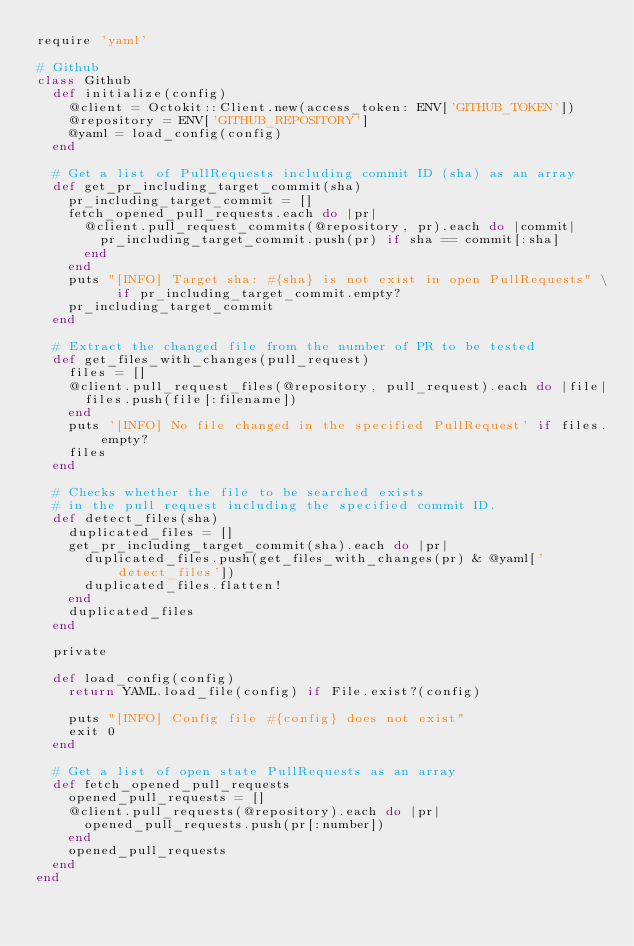<code> <loc_0><loc_0><loc_500><loc_500><_Ruby_>require 'yaml'

# Github
class Github
  def initialize(config)
    @client = Octokit::Client.new(access_token: ENV['GITHUB_TOKEN'])
    @repository = ENV['GITHUB_REPOSITORY']
    @yaml = load_config(config)
  end

  # Get a list of PullRequests including commit ID (sha) as an array
  def get_pr_including_target_commit(sha)
    pr_including_target_commit = []
    fetch_opened_pull_requests.each do |pr|
      @client.pull_request_commits(@repository, pr).each do |commit|
        pr_including_target_commit.push(pr) if sha == commit[:sha]
      end
    end
    puts "[INFO] Target sha: #{sha} is not exist in open PullRequests" \
          if pr_including_target_commit.empty?
    pr_including_target_commit
  end

  # Extract the changed file from the number of PR to be tested
  def get_files_with_changes(pull_request)
    files = []
    @client.pull_request_files(@repository, pull_request).each do |file|
      files.push(file[:filename])
    end
    puts '[INFO] No file changed in the specified PullRequest' if files.empty?
    files
  end

  # Checks whether the file to be searched exists
  # in the pull request including the specified commit ID.
  def detect_files(sha)
    duplicated_files = []
    get_pr_including_target_commit(sha).each do |pr|
      duplicated_files.push(get_files_with_changes(pr) & @yaml['detect_files'])
      duplicated_files.flatten!
    end
    duplicated_files
  end

  private

  def load_config(config)
    return YAML.load_file(config) if File.exist?(config)

    puts "[INFO] Config file #{config} does not exist"
    exit 0
  end

  # Get a list of open state PullRequests as an array
  def fetch_opened_pull_requests
    opened_pull_requests = []
    @client.pull_requests(@repository).each do |pr|
      opened_pull_requests.push(pr[:number])
    end
    opened_pull_requests
  end
end
</code> 